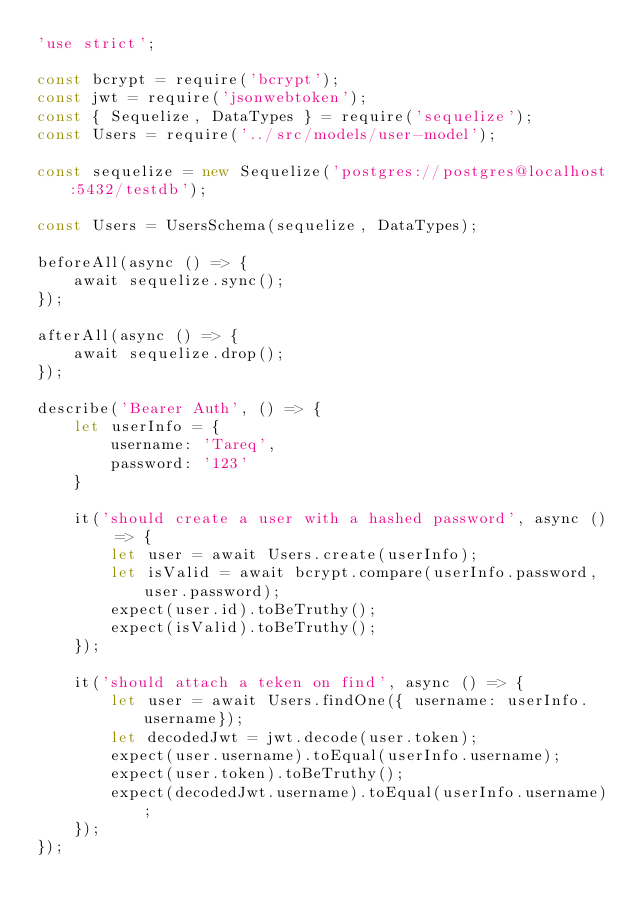<code> <loc_0><loc_0><loc_500><loc_500><_JavaScript_>'use strict';

const bcrypt = require('bcrypt');
const jwt = require('jsonwebtoken');
const { Sequelize, DataTypes } = require('sequelize');
const Users = require('../src/models/user-model');

const sequelize = new Sequelize('postgres://postgres@localhost:5432/testdb');

const Users = UsersSchema(sequelize, DataTypes);

beforeAll(async () => {
    await sequelize.sync();
});

afterAll(async () => {
    await sequelize.drop();
});

describe('Bearer Auth', () => {
    let userInfo = {
        username: 'Tareq',
        password: '123'
    }

    it('should create a user with a hashed password', async () => {
        let user = await Users.create(userInfo);  
        let isValid = await bcrypt.compare(userInfo.password, user.password);
        expect(user.id).toBeTruthy();
        expect(isValid).toBeTruthy();
    });

    it('should attach a teken on find', async () => {
        let user = await Users.findOne({ username: userInfo.username});
        let decodedJwt = jwt.decode(user.token);
        expect(user.username).toEqual(userInfo.username);
        expect(user.token).toBeTruthy();
        expect(decodedJwt.username).toEqual(userInfo.username);
    });
});</code> 